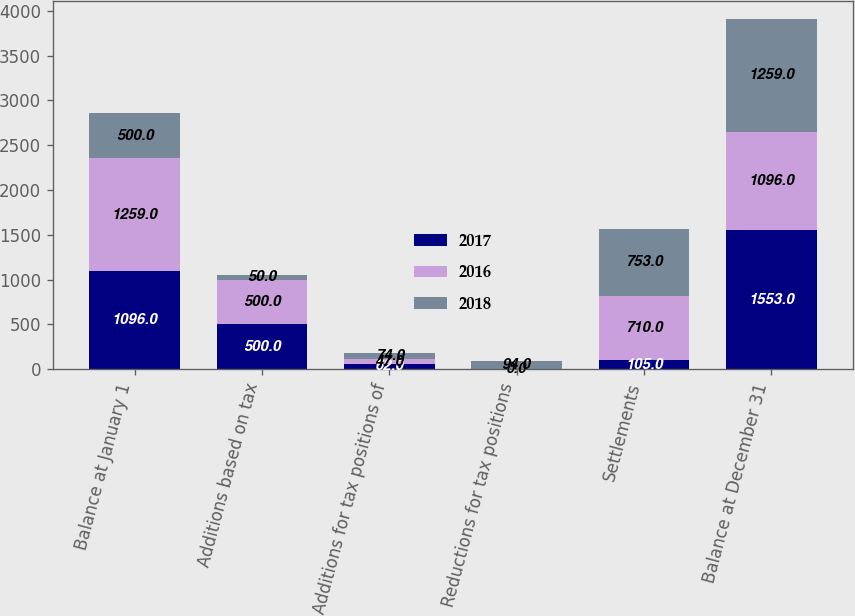Convert chart. <chart><loc_0><loc_0><loc_500><loc_500><stacked_bar_chart><ecel><fcel>Balance at January 1<fcel>Additions based on tax<fcel>Additions for tax positions of<fcel>Reductions for tax positions<fcel>Settlements<fcel>Balance at December 31<nl><fcel>2017<fcel>1096<fcel>500<fcel>62<fcel>0<fcel>105<fcel>1553<nl><fcel>2016<fcel>1259<fcel>500<fcel>47<fcel>0<fcel>710<fcel>1096<nl><fcel>2018<fcel>500<fcel>50<fcel>74<fcel>94<fcel>753<fcel>1259<nl></chart> 